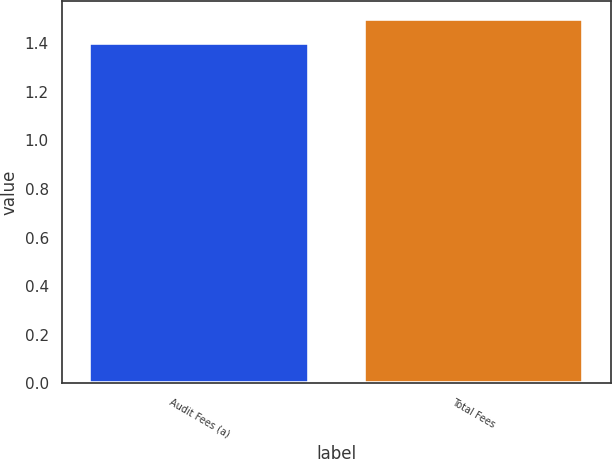<chart> <loc_0><loc_0><loc_500><loc_500><bar_chart><fcel>Audit Fees (a)<fcel>Total Fees<nl><fcel>1.4<fcel>1.5<nl></chart> 